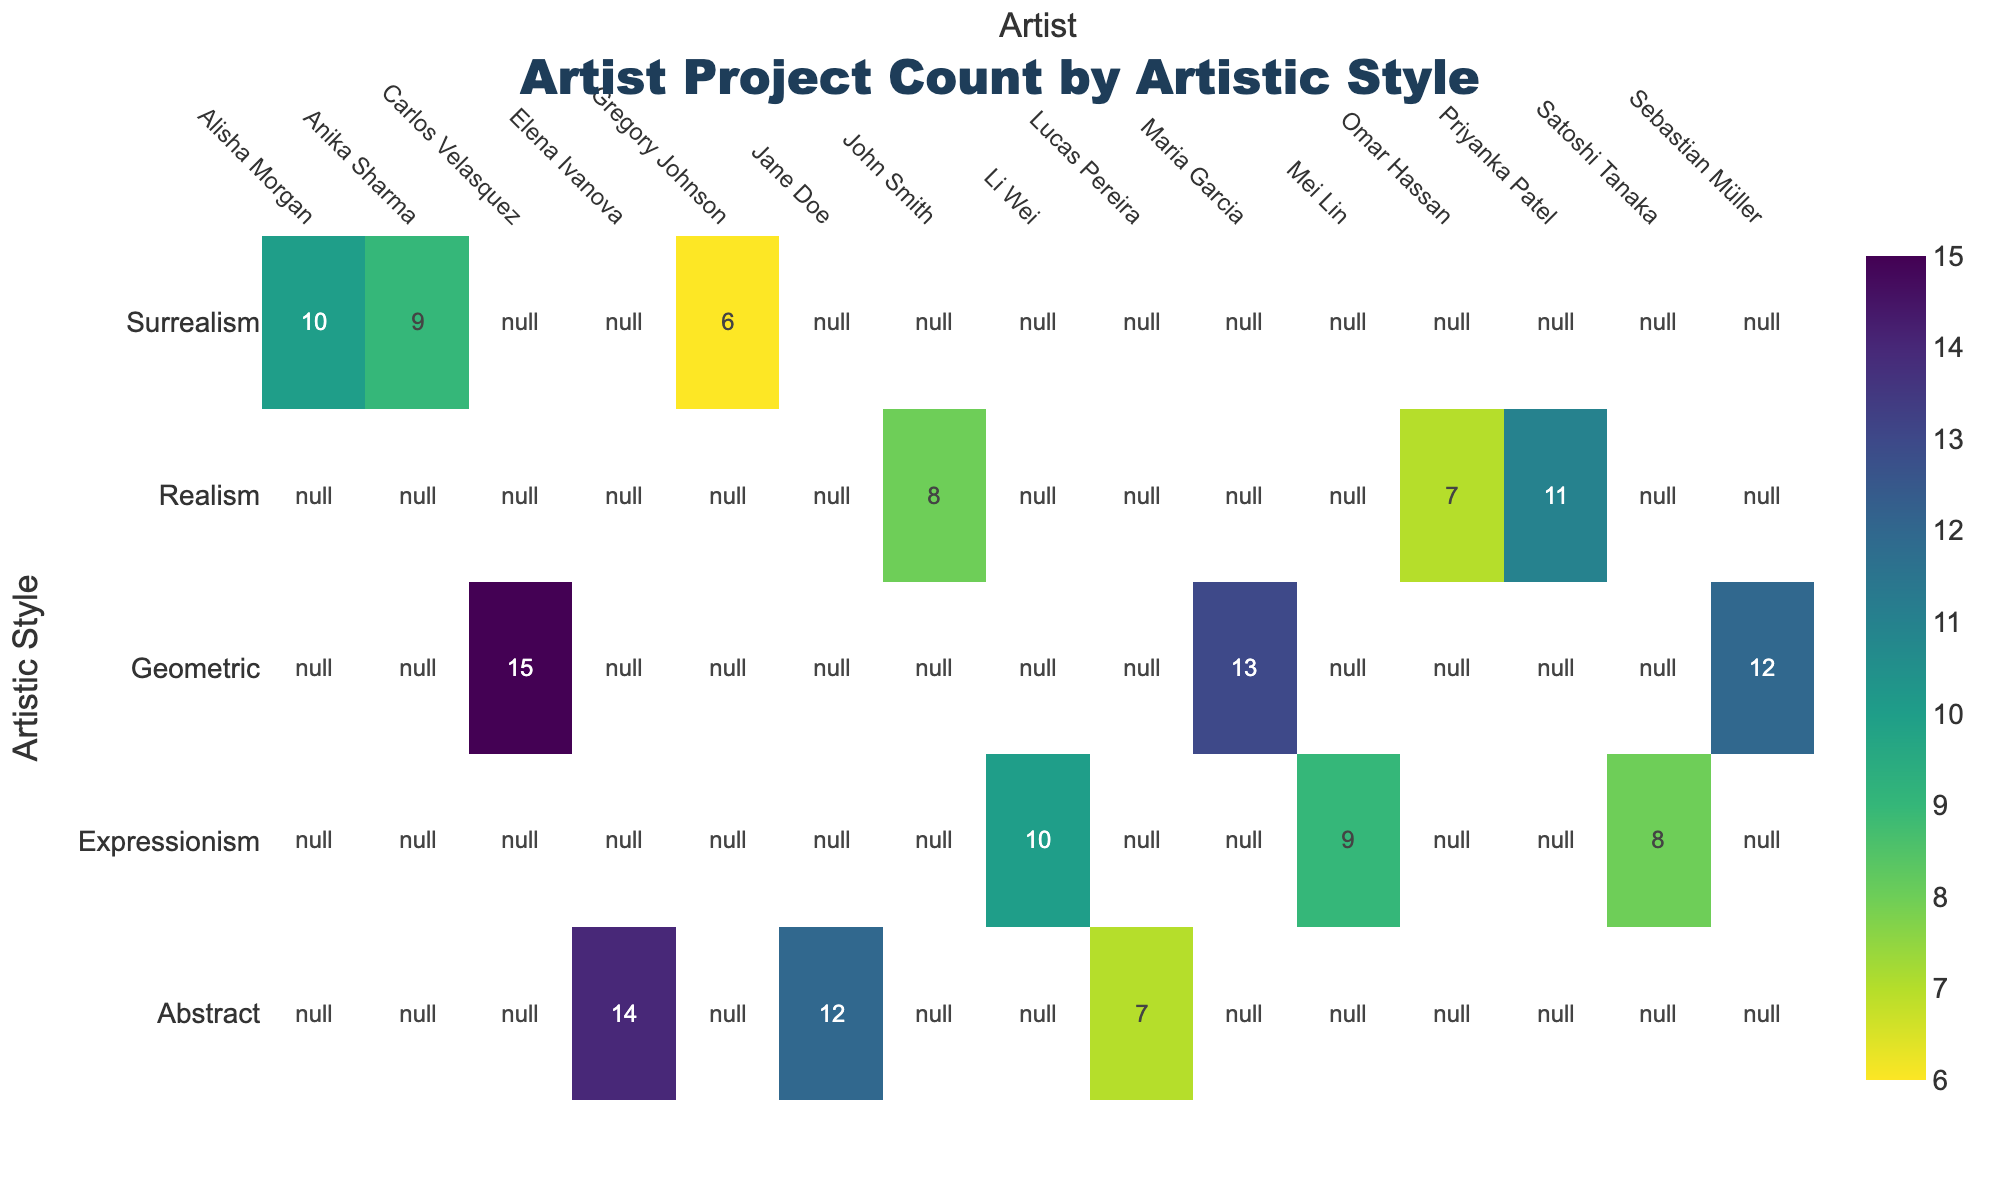What's the title of the figure? The title is prominently displayed at the top center of the figure. It is often in a larger font size than the rest of the text.
Answer: Artist Project Count by Artistic Style Which artistic style has the highest number of projects for a single artist? By scanning the heatmap for the highest value, we can see that Carlos Velasquez (Geometric) has the highest project count with 15 projects.
Answer: Geometric (Carlos Velasquez, 15) What is the total number of projects for artists working in Abstract style? Summing the project counts for all artists in the Abstract style: 12 + 7 + 14 = 33.
Answer: 33 How does Mei Lin's project count compare to Li Wei's? Mei Lin and Li Wei's data is located on different rows. Mei Lin (Expressionism) has 9 projects, while Li Wei (Expressionism) has 10 projects. 9 is less than 10.
Answer: Mei Lin has fewer projects (9 vs. 10) Which artistic style has the most diverse set of project counts among artists? By observing the variation in numbers within each row, Abstract has a wide range (7 to 14), indicating diversity in project counts among artists.
Answer: Abstract Who has the fewest projects in Realism, and how many? Scanning the Realism row for the lowest value, Omar Hassan has the fewest projects with 7.
Answer: Omar Hassan, 7 What's the average project count for artists specializing in Geometric style? Calculating the average for Geometric: (15 + 13 + 12)/3 = 40/3 ≈ 13.33.
Answer: Approximately 13.33 Does Surrealism have a higher total project count than Realism? Summing the Surrealism counts (10 + 6 + 9 = 25) and Realism counts (8 + 11 + 7 = 26). Surrealism total is 25, which is less than Realism total 26.
Answer: No, Realism has a higher total Which artist has participated in the most projects across all artistic styles? By scanning for the highest single project count across the entire heatmap, we find Carlos Velasquez in Geometric style with 15 projects.
Answer: Carlos Velasquez Does any artist have the same number of projects in Abstract and another style? By comparing project counts across different styles, Elena Ivanova (Abstract) and Maria Garcia (Geometric) both have 14 projects.
Answer: Yes, Elena Ivanova and Maria Garcia (14) 